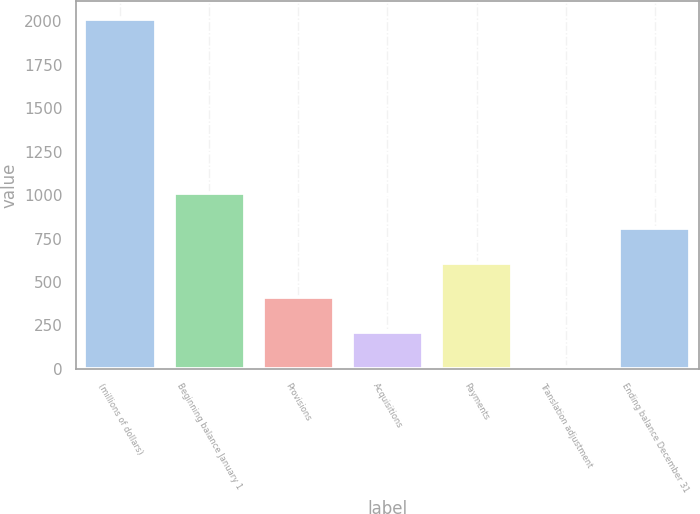<chart> <loc_0><loc_0><loc_500><loc_500><bar_chart><fcel>(millions of dollars)<fcel>Beginning balance January 1<fcel>Provisions<fcel>Acquisitions<fcel>Payments<fcel>Translation adjustment<fcel>Ending balance December 31<nl><fcel>2015<fcel>1012.65<fcel>411.24<fcel>210.77<fcel>611.71<fcel>10.3<fcel>812.18<nl></chart> 